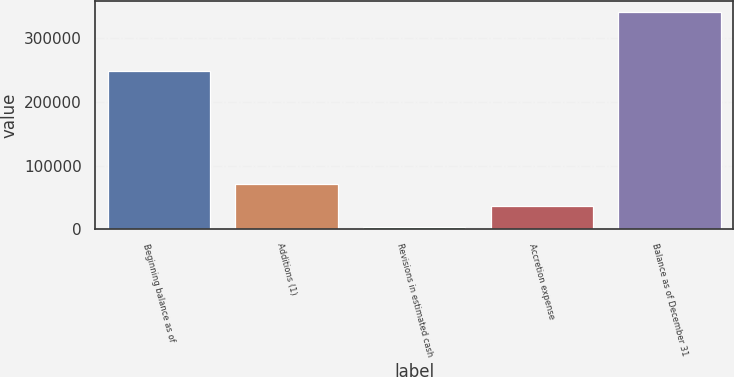Convert chart. <chart><loc_0><loc_0><loc_500><loc_500><bar_chart><fcel>Beginning balance as of<fcel>Additions (1)<fcel>Revisions in estimated cash<fcel>Accretion expense<fcel>Balance as of December 31<nl><fcel>247839<fcel>71399<fcel>3341<fcel>37123.1<fcel>341162<nl></chart> 